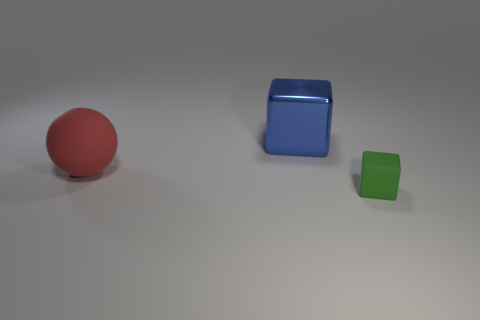What number of things have the same material as the large block?
Make the answer very short. 0. There is a cube behind the green object; does it have the same size as the small rubber block?
Provide a succinct answer. No. The big thing that is made of the same material as the tiny green object is what color?
Offer a very short reply. Red. Is there any other thing that is the same size as the blue metal thing?
Your answer should be compact. Yes. There is a red rubber thing; what number of big balls are behind it?
Offer a very short reply. 0. Do the rubber thing behind the green cube and the cube that is to the left of the matte block have the same color?
Make the answer very short. No. What color is the other small thing that is the same shape as the metallic thing?
Offer a terse response. Green. Is there anything else that has the same shape as the shiny object?
Provide a short and direct response. Yes. Do the rubber object that is on the right side of the big cube and the big object that is behind the large red rubber thing have the same shape?
Offer a terse response. Yes. Do the rubber ball and the cube that is behind the small object have the same size?
Make the answer very short. Yes. 